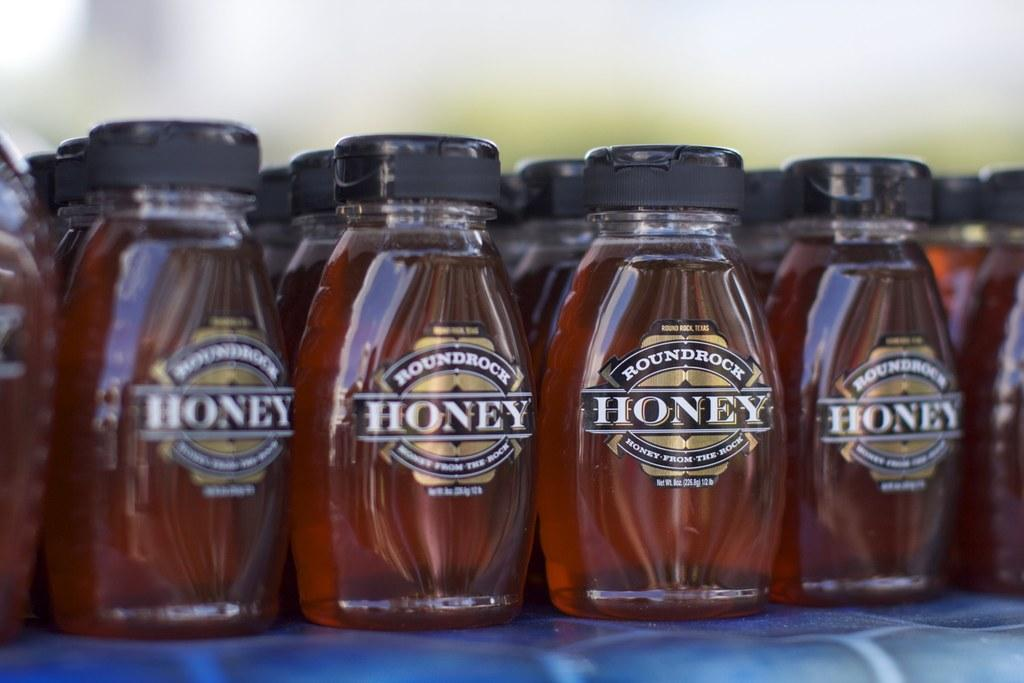<image>
Give a short and clear explanation of the subsequent image. A row of Roundrock Honey on a blue table. 